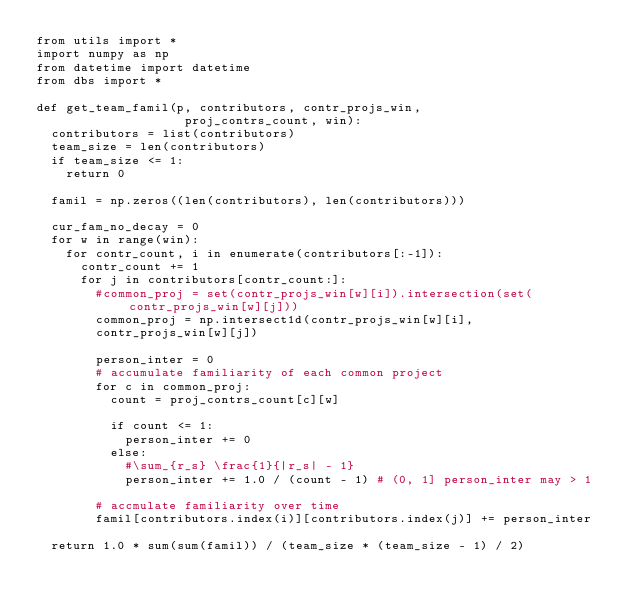Convert code to text. <code><loc_0><loc_0><loc_500><loc_500><_Python_>from utils import *
import numpy as np
from datetime import datetime
from dbs import *

def get_team_famil(p, contributors, contr_projs_win,
                    proj_contrs_count, win):
  contributors = list(contributors)
  team_size = len(contributors)
  if team_size <= 1:
    return 0

  famil = np.zeros((len(contributors), len(contributors)))

  cur_fam_no_decay = 0
  for w in range(win):
    for contr_count, i in enumerate(contributors[:-1]):
      contr_count += 1
      for j in contributors[contr_count:]:
        #common_proj = set(contr_projs_win[w][i]).intersection(set(contr_projs_win[w][j]))
        common_proj = np.intersect1d(contr_projs_win[w][i],
        contr_projs_win[w][j])

        person_inter = 0
        # accumulate familiarity of each common project
        for c in common_proj:
          count = proj_contrs_count[c][w]

          if count <= 1:
            person_inter += 0
          else:
            #\sum_{r_s} \frac{1}{|r_s| - 1}
            person_inter += 1.0 / (count - 1) # (0, 1] person_inter may > 1

        # accmulate familiarity over time
        famil[contributors.index(i)][contributors.index(j)] += person_inter 

  return 1.0 * sum(sum(famil)) / (team_size * (team_size - 1) / 2)
</code> 